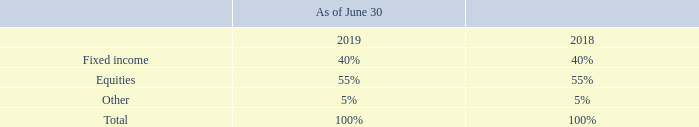The defined benefit pension plan utilizes various investment securities. Generally, investment securities are exposed to various risks, such as interest rate risks, credit risk, and overall market volatility. Due to the level of risk associated with certain investment securities, it is reasonably possible that changes in the values of investment securities will occur and that such changes could materially affect the amounts reported.
The following table presents the Company’s target for the allocation of invested defined benefit pension plan assets at June 30, 2019 and June 30, 2018:
What types of risks are investment securities exposed to? Generally, investment securities are exposed to various risks, such as interest rate risks, credit risk, and overall market volatility. Why is it possible that changes in the values of investment securities will occur? Due to the level of risk associated with certain investment securities, it is reasonably possible that changes in the values of investment securities will occur. What was the company's target for the allocation of fixed income at June 30, 2019? 40%. Which pension plan assets had the highest allocation at June 30, 2019? 55% > 40% > 5%
Answer: equities. What was the proportion of equities to fixed income for 2018?
Answer scale should be: percent. 55%/40%
Answer: 137.5. What is the change in the allocation of equities from 2018 to 2019?
Answer scale should be: percent. 55%-55%
Answer: 0. 